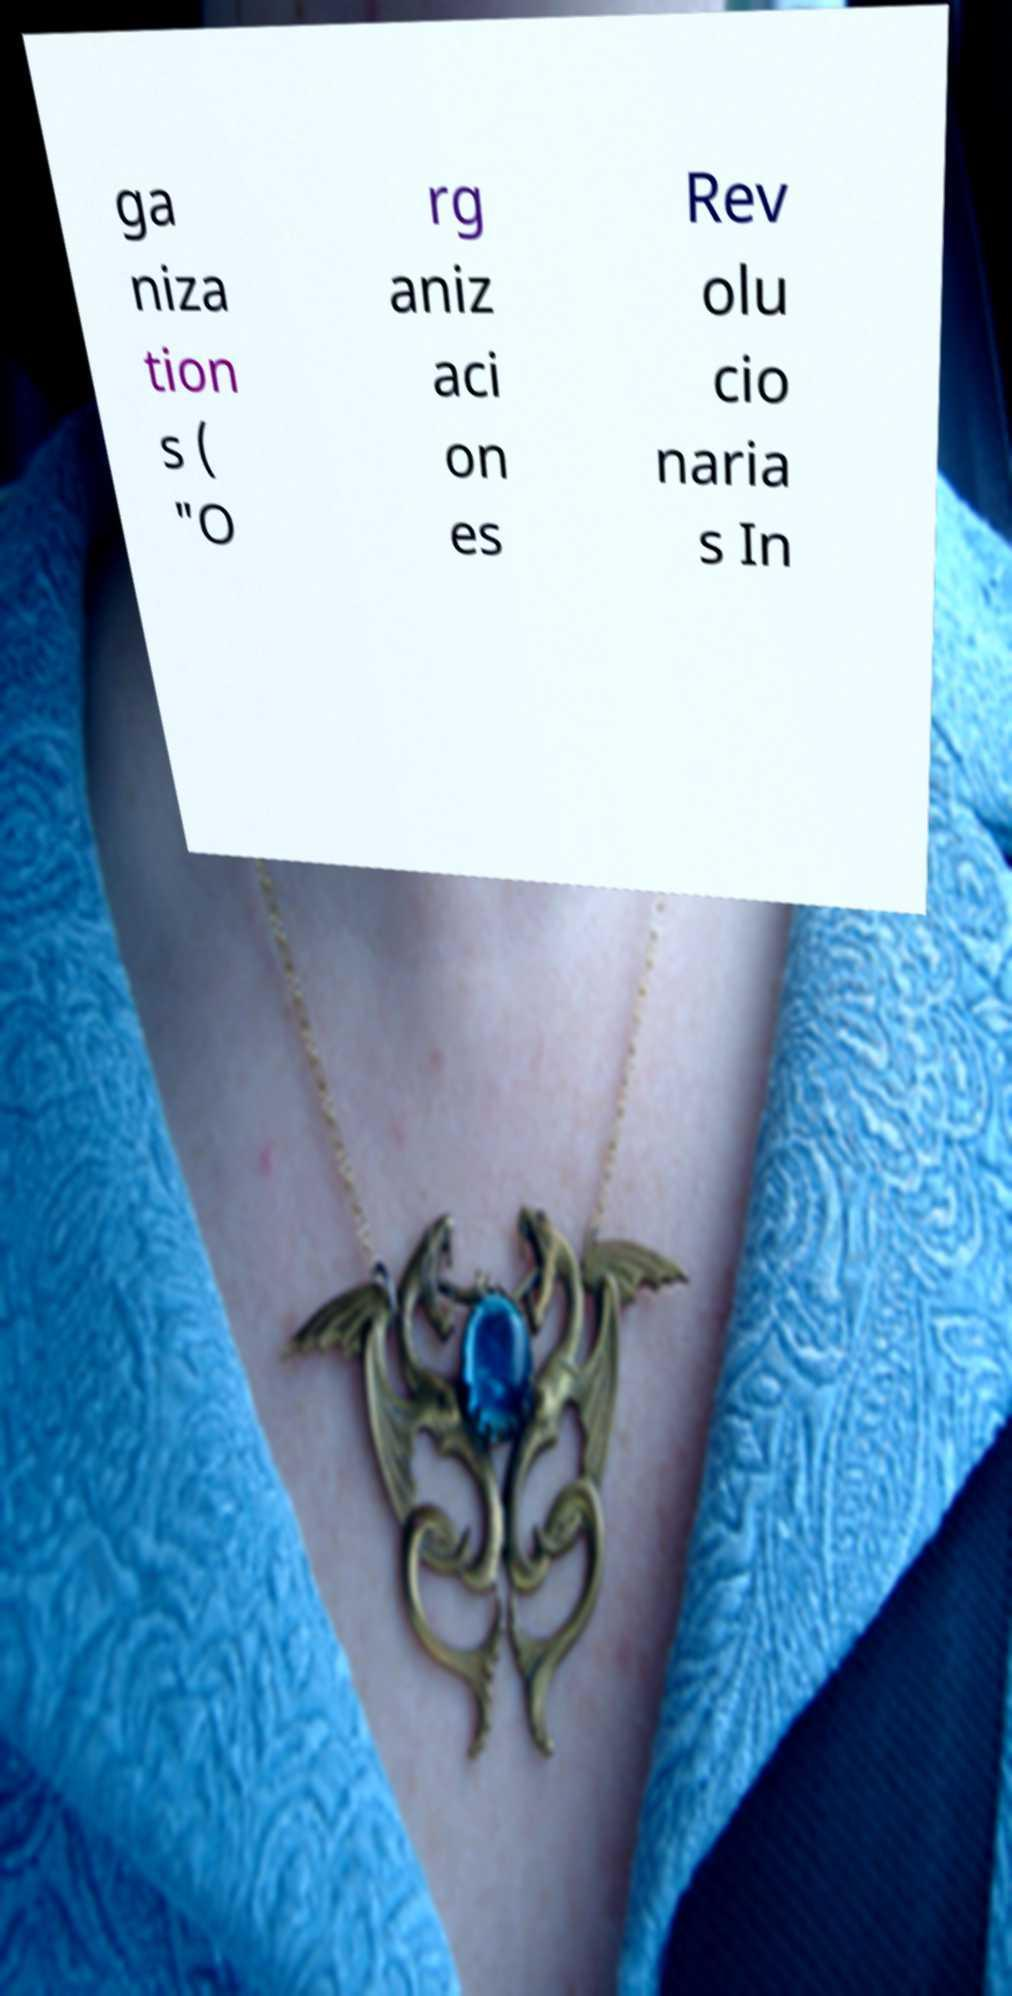I need the written content from this picture converted into text. Can you do that? ga niza tion s ( "O rg aniz aci on es Rev olu cio naria s In 